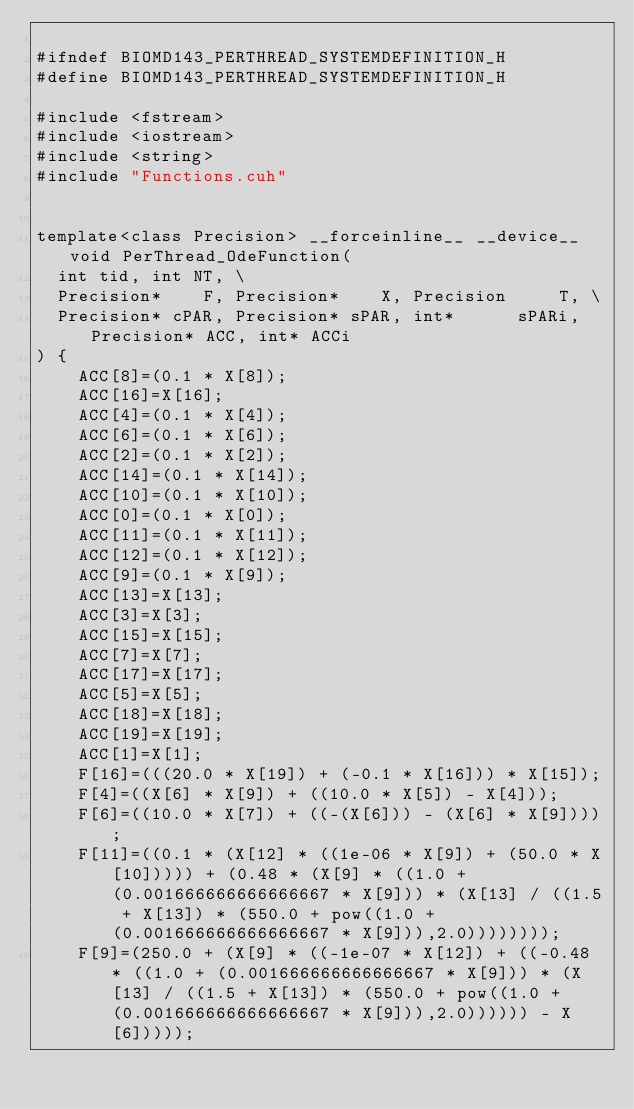<code> <loc_0><loc_0><loc_500><loc_500><_Cuda_>
#ifndef BIOMD143_PERTHREAD_SYSTEMDEFINITION_H
#define BIOMD143_PERTHREAD_SYSTEMDEFINITION_H

#include <fstream>
#include <iostream>
#include <string>
#include "Functions.cuh"


template<class Precision> __forceinline__ __device__ void PerThread_OdeFunction(
	int tid, int NT, \
	Precision*    F, Precision*    X, Precision     T, \
	Precision* cPAR, Precision* sPAR, int*      sPARi, Precision* ACC, int* ACCi  		
) {
    ACC[8]=(0.1 * X[8]);
    ACC[16]=X[16];
    ACC[4]=(0.1 * X[4]);
    ACC[6]=(0.1 * X[6]);
    ACC[2]=(0.1 * X[2]);
    ACC[14]=(0.1 * X[14]);
    ACC[10]=(0.1 * X[10]);
    ACC[0]=(0.1 * X[0]);
    ACC[11]=(0.1 * X[11]);
    ACC[12]=(0.1 * X[12]);
    ACC[9]=(0.1 * X[9]);
    ACC[13]=X[13];
    ACC[3]=X[3];
    ACC[15]=X[15];
    ACC[7]=X[7];
    ACC[17]=X[17];
    ACC[5]=X[5];
    ACC[18]=X[18];
    ACC[19]=X[19];
    ACC[1]=X[1];
    F[16]=(((20.0 * X[19]) + (-0.1 * X[16])) * X[15]);
    F[4]=((X[6] * X[9]) + ((10.0 * X[5]) - X[4]));
    F[6]=((10.0 * X[7]) + ((-(X[6])) - (X[6] * X[9])));
    F[11]=((0.1 * (X[12] * ((1e-06 * X[9]) + (50.0 * X[10])))) + (0.48 * (X[9] * ((1.0 + (0.001666666666666667 * X[9])) * (X[13] / ((1.5 + X[13]) * (550.0 + pow((1.0 + (0.001666666666666667 * X[9])),2.0))))))));
    F[9]=(250.0 + (X[9] * ((-1e-07 * X[12]) + ((-0.48 * ((1.0 + (0.001666666666666667 * X[9])) * (X[13] / ((1.5 + X[13]) * (550.0 + pow((1.0 + (0.001666666666666667 * X[9])),2.0)))))) - X[6]))));</code> 